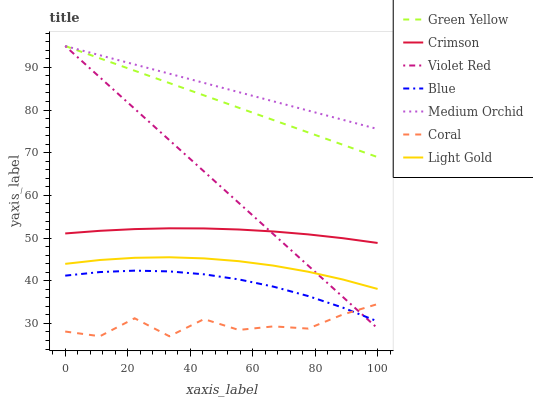Does Coral have the minimum area under the curve?
Answer yes or no. Yes. Does Medium Orchid have the maximum area under the curve?
Answer yes or no. Yes. Does Violet Red have the minimum area under the curve?
Answer yes or no. No. Does Violet Red have the maximum area under the curve?
Answer yes or no. No. Is Violet Red the smoothest?
Answer yes or no. Yes. Is Coral the roughest?
Answer yes or no. Yes. Is Coral the smoothest?
Answer yes or no. No. Is Violet Red the roughest?
Answer yes or no. No. Does Coral have the lowest value?
Answer yes or no. Yes. Does Violet Red have the lowest value?
Answer yes or no. No. Does Green Yellow have the highest value?
Answer yes or no. Yes. Does Coral have the highest value?
Answer yes or no. No. Is Blue less than Crimson?
Answer yes or no. Yes. Is Crimson greater than Blue?
Answer yes or no. Yes. Does Coral intersect Violet Red?
Answer yes or no. Yes. Is Coral less than Violet Red?
Answer yes or no. No. Is Coral greater than Violet Red?
Answer yes or no. No. Does Blue intersect Crimson?
Answer yes or no. No. 